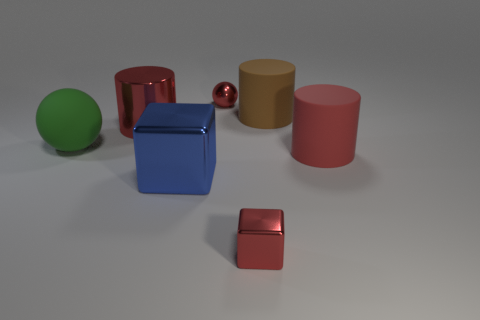Add 2 small blue shiny balls. How many objects exist? 9 Subtract all matte cylinders. How many cylinders are left? 1 Subtract all red balls. How many balls are left? 1 Subtract all cyan blocks. How many red cylinders are left? 2 Add 4 tiny red objects. How many tiny red objects are left? 6 Add 5 small red metallic blocks. How many small red metallic blocks exist? 6 Subtract 0 purple balls. How many objects are left? 7 Subtract all cylinders. How many objects are left? 4 Subtract 3 cylinders. How many cylinders are left? 0 Subtract all cyan cylinders. Subtract all purple blocks. How many cylinders are left? 3 